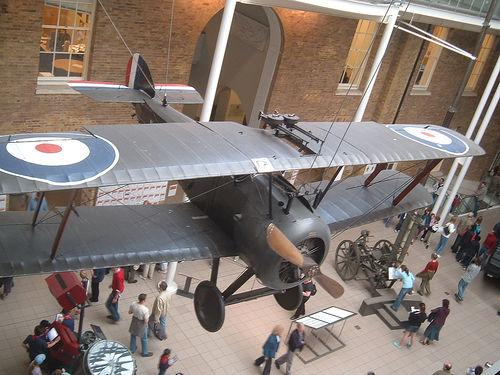Question: what is hanging from wires?
Choices:
A. Your shoes.
B. A car.
C. Jumper cables.
D. An airplane.
Answer with the letter. Answer: D Question: what is the color of the body of the plane?
Choices:
A. Grey.
B. Blue.
C. Orange.
D. White.
Answer with the letter. Answer: A Question: why is the airplane hanging?
Choices:
A. It's under construction.
B. It crashed that way.
C. It's on display.
D. They forgot to take it down.
Answer with the letter. Answer: C Question: who is in the plane?
Choices:
A. The pilot.
B. Nobody.
C. Some passengers.
D. A flight attendant.
Answer with the letter. Answer: B Question: when was this photo taken?
Choices:
A. Evening.
B. Night time.
C. Dayime.
D. Early morning.
Answer with the letter. Answer: C Question: how many windows are on the second story of the building?
Choices:
A. 2.
B. 6.
C. 4.
D. 8.
Answer with the letter. Answer: C 